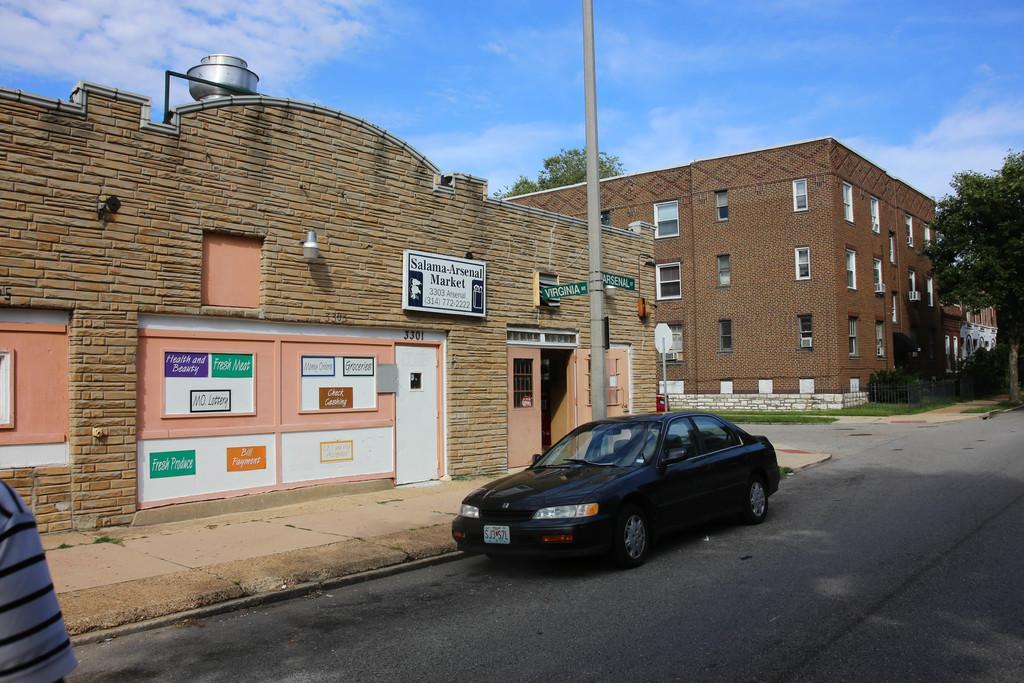In one or two sentences, can you explain what this image depicts? In this image I can see few buildings, windows, number of boards, few trees, clouds, the sky, grass and a black colour car over here. On these boards I can see something is written and I can also see few doors. 